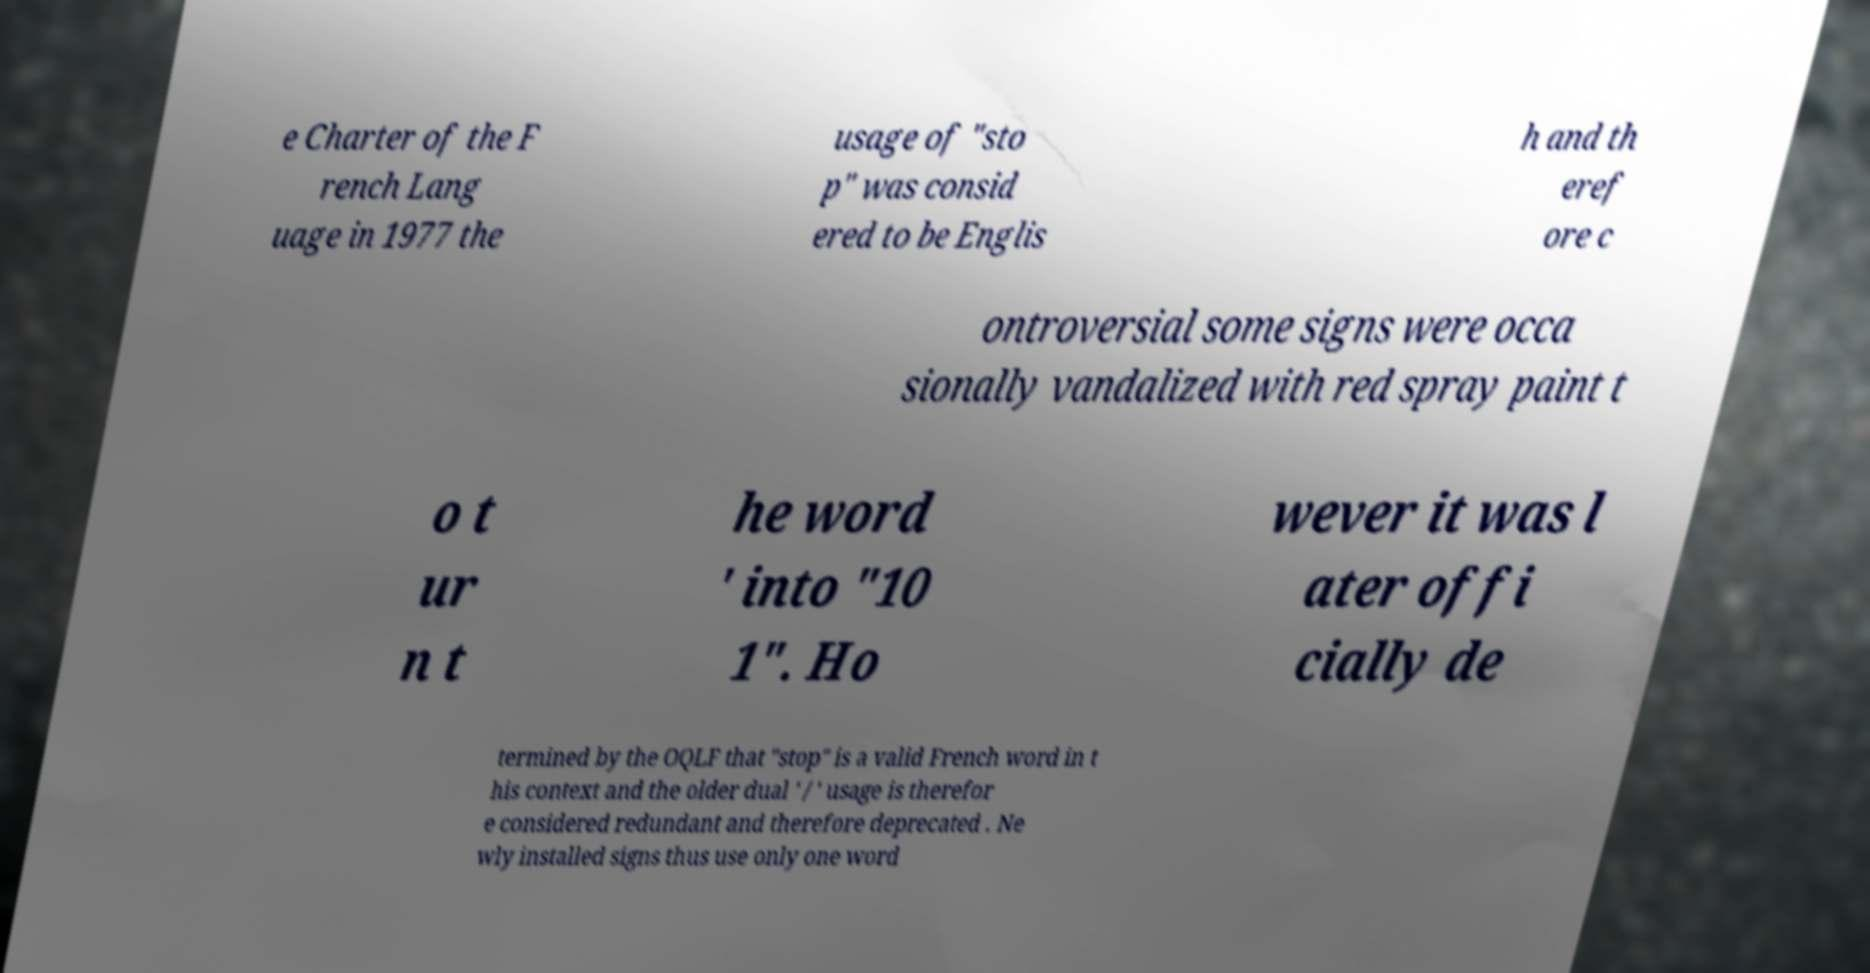What messages or text are displayed in this image? I need them in a readable, typed format. e Charter of the F rench Lang uage in 1977 the usage of "sto p" was consid ered to be Englis h and th eref ore c ontroversial some signs were occa sionally vandalized with red spray paint t o t ur n t he word ' into "10 1". Ho wever it was l ater offi cially de termined by the OQLF that "stop" is a valid French word in t his context and the older dual ' / ' usage is therefor e considered redundant and therefore deprecated . Ne wly installed signs thus use only one word 